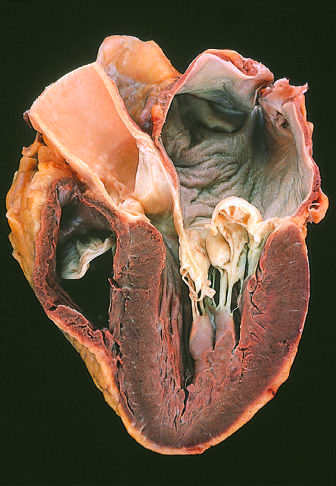what is there with prolapse of the posterior mitral leaflet into the left atrium?
Answer the question using a single word or phrase. Prominent hooding 